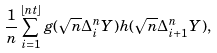<formula> <loc_0><loc_0><loc_500><loc_500>\frac { 1 } { n } \sum _ { i = 1 } ^ { \left \lfloor n t \right \rfloor } g ( \sqrt { n } \Delta _ { i } ^ { n } Y ) h ( \sqrt { n } \Delta _ { i + 1 } ^ { n } Y ) ,</formula> 